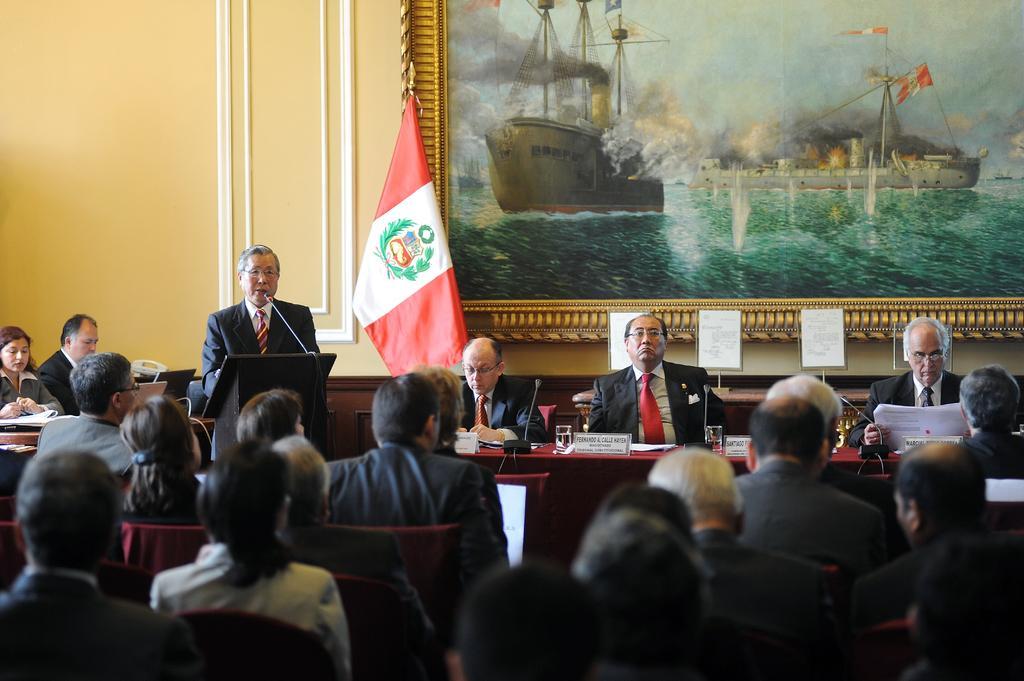In one or two sentences, can you explain what this image depicts? In this image there are group of persons sitting and standing. In the background there is a frame on the wall and in front of the wall there is a flag which is red and white in colour. On the left side in the center there is a man standing and in front of the man there is a podium and a mic. 